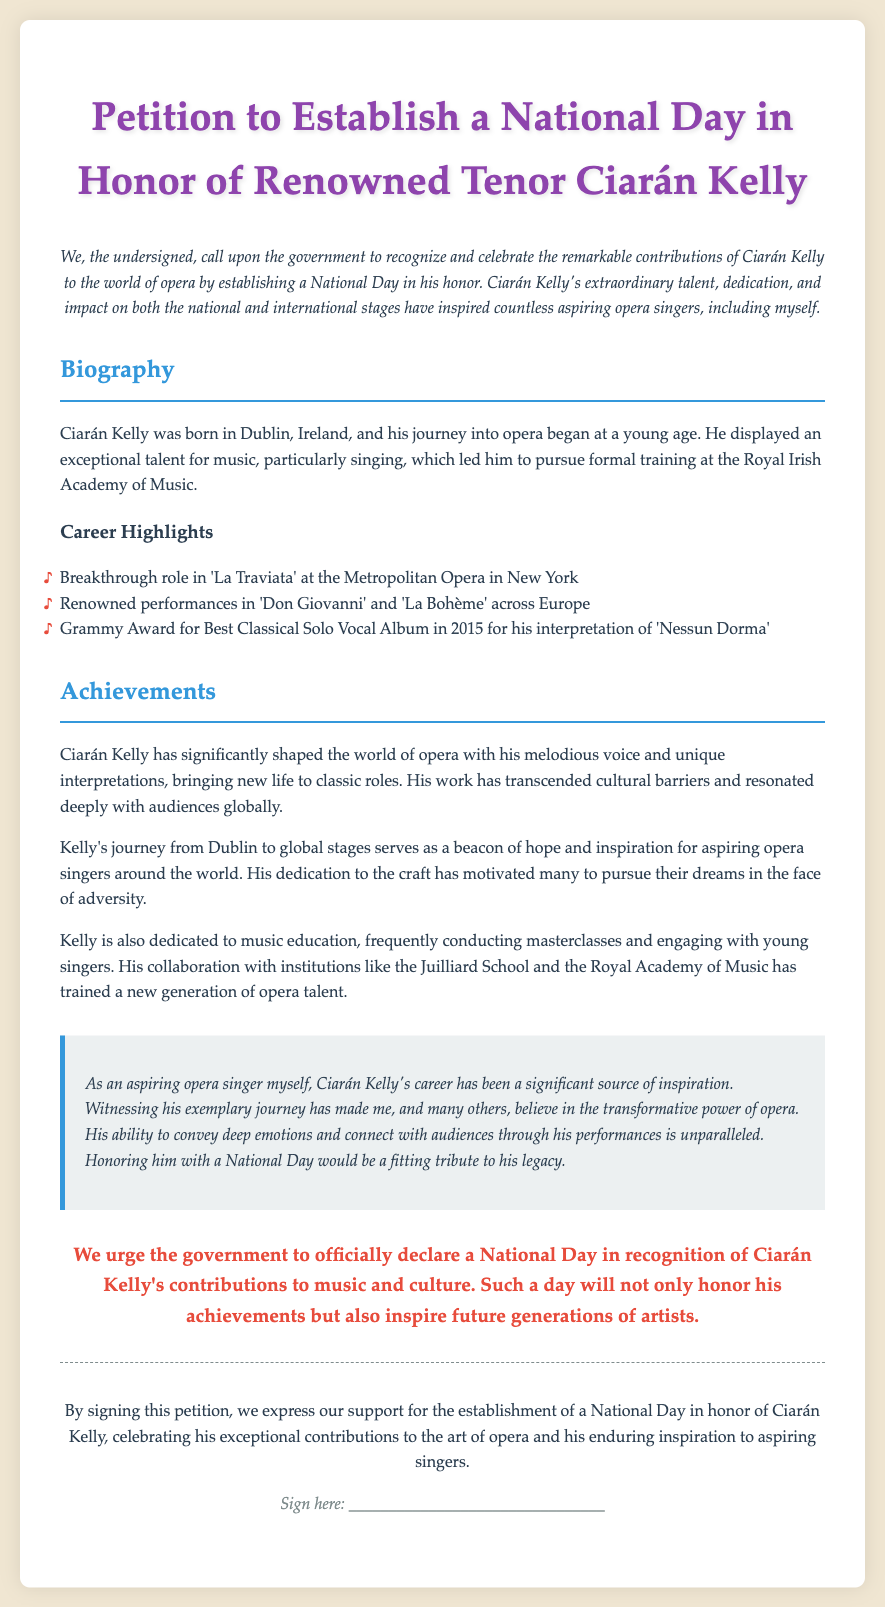what is the title of the petition? The title of the petition is stated prominently at the top of the document.
Answer: Petition to Establish a National Day in Honor of Renowned Tenor Ciarán Kelly who is the subject of the petition? The subject of the petition is mentioned in the title and throughout the document.
Answer: Ciarán Kelly where was Ciarán Kelly born? The document provides this information in his biography section.
Answer: Dublin, Ireland what year did Ciarán Kelly win a Grammy Award? The document specifies the year he received this award.
Answer: 2015 which opera role marked Ciarán Kelly's breakthrough? The document mentions this specific role.
Answer: La Traviata what is the main purpose of the petition? The introduction outlines the intent of the petition clearly.
Answer: To recognize and celebrate Ciarán Kelly's contributions how does Ciarán Kelly inspire aspiring opera singers? The testimonial gives details on how he serves as a source of inspiration.
Answer: By conveying deep emotions and connecting with audiences what is the call to action in the petition? The call to action is summarized at the end of the document.
Answer: Urge the government to officially declare a National Day what type of educational engagement does Ciarán Kelly have? The achievements section describes his involvement with young singers.
Answer: Conducting masterclasses 